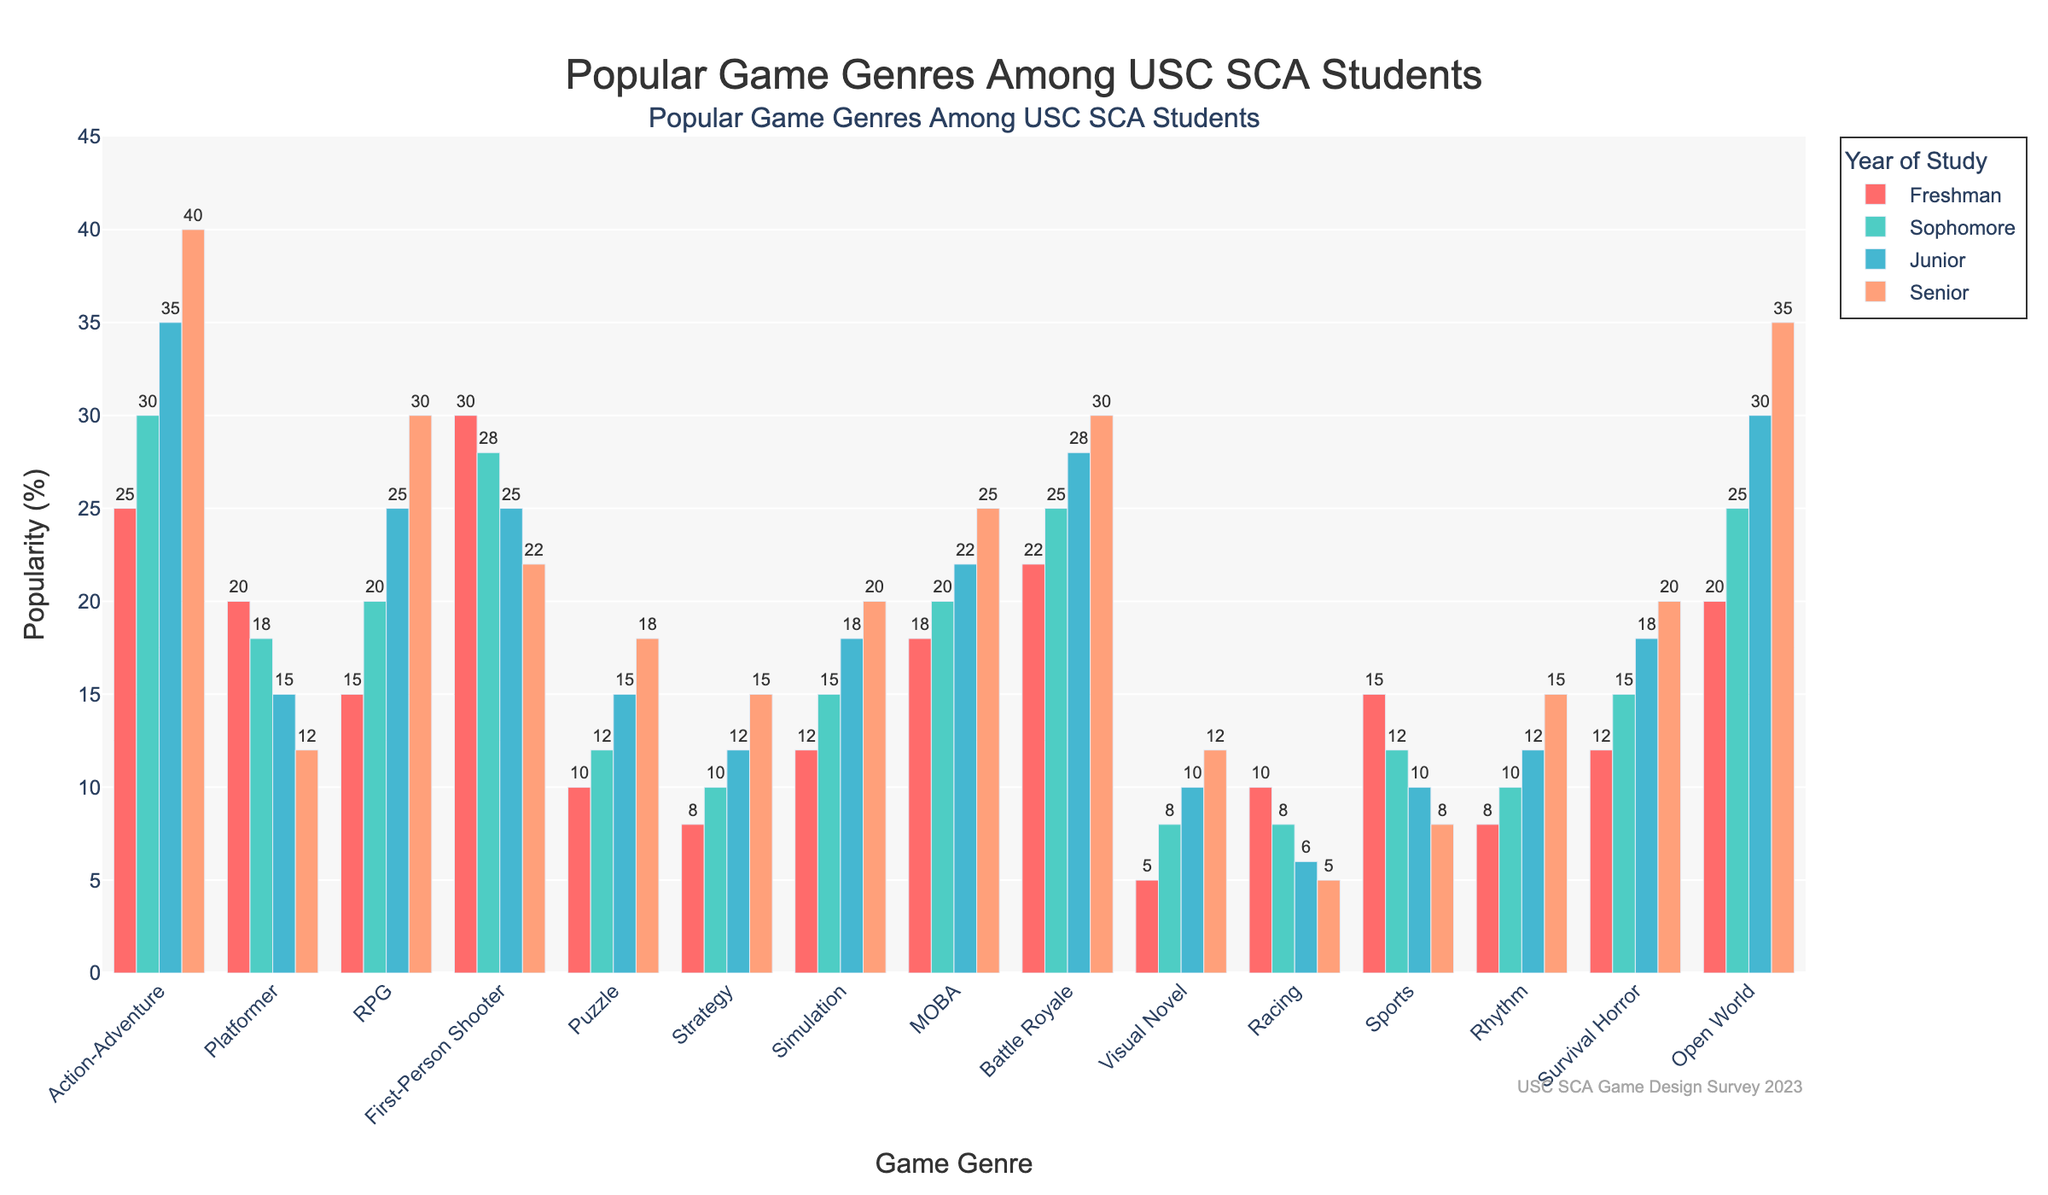What is the most popular game genre among freshmen? The action-adventure genre has 25 freshmen, which is the highest value among all genres for freshmen.
Answer: Action-Adventure How does the popularity of the battle royale genre change from freshmen to seniors? The battle royale genre starts with 22 among freshmen, increases to 25 for sophomores, then to 28 for juniors, and finally 30 for seniors. So, it shows a steady increase.
Answer: It increases steadily Which genre saw the largest increase in popularity from freshmen to seniors? Comparing the difference from freshmen to seniors for all genres, action-adventure increased by 15, RPG by 15, and open world by 15. These are the largest increases.
Answer: Action-Adventure, RPG, Open World (each increased by 15) Among juniors, which genre is more popular: strategy or rhythm? For juniors, the popularity of the strategy genre is 12, while the rhythm genre is 12 as well. Both genres have the same count.
Answer: Both are equally popular What is the total popularity of simulation games across all years? Summing up the values for simulation: 12 (freshmen) + 15 (sophomores) + 18 (juniors) + 20 (seniors). This equals 65.
Answer: 65 What color represents the sophomore year in the bar chart? The colors are specified with green for sophomores.
Answer: Green If you combine the popularity percentages of RPG and MOBA for seniors, what percentage do you get? For seniors, RPG is 30, and MOBA is 25. Adding these, we get 55.
Answer: 55 Which year has the highest preference for the visual novel genre? The preference for visual novel genre among seniors is highest with 12 students.
Answer: Senior Is the racing genre more popular among freshmen or sophomores? For freshmen, the racing genre has a value of 10. For sophomores, it is 8. Thus, it is more popular among freshmen.
Answer: Freshmen What trend do you observe for the popularity of sports games from freshmen to seniors? Sports games' popularity decreases over the years: 15 (freshmen), 12 (sophomores), 10 (juniors), and 8 (seniors).
Answer: It decreases 